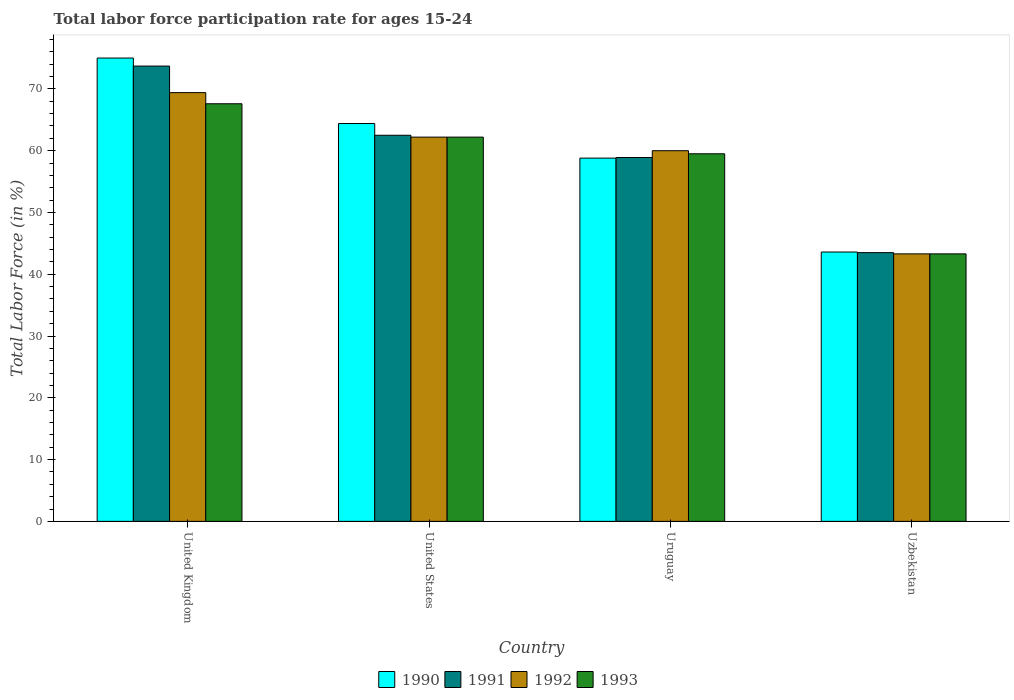How many groups of bars are there?
Give a very brief answer. 4. Are the number of bars per tick equal to the number of legend labels?
Your answer should be very brief. Yes. Are the number of bars on each tick of the X-axis equal?
Offer a terse response. Yes. How many bars are there on the 1st tick from the left?
Your answer should be very brief. 4. How many bars are there on the 4th tick from the right?
Offer a terse response. 4. What is the label of the 2nd group of bars from the left?
Make the answer very short. United States. What is the labor force participation rate in 1991 in Uruguay?
Provide a succinct answer. 58.9. Across all countries, what is the maximum labor force participation rate in 1992?
Keep it short and to the point. 69.4. Across all countries, what is the minimum labor force participation rate in 1991?
Your answer should be compact. 43.5. In which country was the labor force participation rate in 1991 maximum?
Keep it short and to the point. United Kingdom. In which country was the labor force participation rate in 1993 minimum?
Give a very brief answer. Uzbekistan. What is the total labor force participation rate in 1990 in the graph?
Give a very brief answer. 241.8. What is the difference between the labor force participation rate in 1993 in United Kingdom and that in Uruguay?
Your answer should be compact. 8.1. What is the difference between the labor force participation rate in 1991 in United Kingdom and the labor force participation rate in 1990 in Uruguay?
Your answer should be very brief. 14.9. What is the average labor force participation rate in 1993 per country?
Your answer should be very brief. 58.15. What is the difference between the labor force participation rate of/in 1990 and labor force participation rate of/in 1993 in Uzbekistan?
Keep it short and to the point. 0.3. What is the ratio of the labor force participation rate in 1990 in United Kingdom to that in Uzbekistan?
Offer a very short reply. 1.72. Is the labor force participation rate in 1992 in United Kingdom less than that in Uruguay?
Offer a very short reply. No. Is the difference between the labor force participation rate in 1990 in United States and Uzbekistan greater than the difference between the labor force participation rate in 1993 in United States and Uzbekistan?
Make the answer very short. Yes. What is the difference between the highest and the second highest labor force participation rate in 1993?
Your response must be concise. -8.1. What is the difference between the highest and the lowest labor force participation rate in 1990?
Make the answer very short. 31.4. In how many countries, is the labor force participation rate in 1991 greater than the average labor force participation rate in 1991 taken over all countries?
Give a very brief answer. 2. Is the sum of the labor force participation rate in 1991 in Uruguay and Uzbekistan greater than the maximum labor force participation rate in 1992 across all countries?
Provide a succinct answer. Yes. Is it the case that in every country, the sum of the labor force participation rate in 1992 and labor force participation rate in 1991 is greater than the sum of labor force participation rate in 1990 and labor force participation rate in 1993?
Keep it short and to the point. No. Is it the case that in every country, the sum of the labor force participation rate in 1993 and labor force participation rate in 1992 is greater than the labor force participation rate in 1991?
Provide a succinct answer. Yes. How many bars are there?
Your answer should be compact. 16. Are all the bars in the graph horizontal?
Provide a succinct answer. No. How many countries are there in the graph?
Provide a succinct answer. 4. What is the difference between two consecutive major ticks on the Y-axis?
Your answer should be compact. 10. Does the graph contain any zero values?
Your answer should be very brief. No. Does the graph contain grids?
Keep it short and to the point. No. Where does the legend appear in the graph?
Make the answer very short. Bottom center. How are the legend labels stacked?
Your answer should be compact. Horizontal. What is the title of the graph?
Give a very brief answer. Total labor force participation rate for ages 15-24. Does "1965" appear as one of the legend labels in the graph?
Offer a terse response. No. What is the Total Labor Force (in %) in 1991 in United Kingdom?
Provide a succinct answer. 73.7. What is the Total Labor Force (in %) in 1992 in United Kingdom?
Your response must be concise. 69.4. What is the Total Labor Force (in %) in 1993 in United Kingdom?
Offer a terse response. 67.6. What is the Total Labor Force (in %) in 1990 in United States?
Your answer should be compact. 64.4. What is the Total Labor Force (in %) of 1991 in United States?
Offer a very short reply. 62.5. What is the Total Labor Force (in %) of 1992 in United States?
Offer a very short reply. 62.2. What is the Total Labor Force (in %) of 1993 in United States?
Give a very brief answer. 62.2. What is the Total Labor Force (in %) in 1990 in Uruguay?
Offer a very short reply. 58.8. What is the Total Labor Force (in %) of 1991 in Uruguay?
Keep it short and to the point. 58.9. What is the Total Labor Force (in %) of 1992 in Uruguay?
Your response must be concise. 60. What is the Total Labor Force (in %) in 1993 in Uruguay?
Offer a very short reply. 59.5. What is the Total Labor Force (in %) in 1990 in Uzbekistan?
Make the answer very short. 43.6. What is the Total Labor Force (in %) in 1991 in Uzbekistan?
Your answer should be very brief. 43.5. What is the Total Labor Force (in %) in 1992 in Uzbekistan?
Your answer should be compact. 43.3. What is the Total Labor Force (in %) of 1993 in Uzbekistan?
Your response must be concise. 43.3. Across all countries, what is the maximum Total Labor Force (in %) of 1991?
Your answer should be very brief. 73.7. Across all countries, what is the maximum Total Labor Force (in %) in 1992?
Your answer should be very brief. 69.4. Across all countries, what is the maximum Total Labor Force (in %) in 1993?
Ensure brevity in your answer.  67.6. Across all countries, what is the minimum Total Labor Force (in %) in 1990?
Provide a succinct answer. 43.6. Across all countries, what is the minimum Total Labor Force (in %) of 1991?
Provide a short and direct response. 43.5. Across all countries, what is the minimum Total Labor Force (in %) of 1992?
Keep it short and to the point. 43.3. Across all countries, what is the minimum Total Labor Force (in %) in 1993?
Offer a terse response. 43.3. What is the total Total Labor Force (in %) of 1990 in the graph?
Provide a succinct answer. 241.8. What is the total Total Labor Force (in %) of 1991 in the graph?
Your answer should be compact. 238.6. What is the total Total Labor Force (in %) of 1992 in the graph?
Make the answer very short. 234.9. What is the total Total Labor Force (in %) in 1993 in the graph?
Ensure brevity in your answer.  232.6. What is the difference between the Total Labor Force (in %) in 1990 in United Kingdom and that in United States?
Offer a very short reply. 10.6. What is the difference between the Total Labor Force (in %) in 1990 in United Kingdom and that in Uruguay?
Your answer should be very brief. 16.2. What is the difference between the Total Labor Force (in %) of 1990 in United Kingdom and that in Uzbekistan?
Offer a terse response. 31.4. What is the difference between the Total Labor Force (in %) of 1991 in United Kingdom and that in Uzbekistan?
Give a very brief answer. 30.2. What is the difference between the Total Labor Force (in %) of 1992 in United Kingdom and that in Uzbekistan?
Keep it short and to the point. 26.1. What is the difference between the Total Labor Force (in %) of 1993 in United Kingdom and that in Uzbekistan?
Keep it short and to the point. 24.3. What is the difference between the Total Labor Force (in %) in 1990 in United States and that in Uruguay?
Keep it short and to the point. 5.6. What is the difference between the Total Labor Force (in %) of 1990 in United States and that in Uzbekistan?
Your answer should be very brief. 20.8. What is the difference between the Total Labor Force (in %) in 1991 in United States and that in Uzbekistan?
Your answer should be very brief. 19. What is the difference between the Total Labor Force (in %) of 1990 in Uruguay and that in Uzbekistan?
Give a very brief answer. 15.2. What is the difference between the Total Labor Force (in %) in 1992 in Uruguay and that in Uzbekistan?
Provide a succinct answer. 16.7. What is the difference between the Total Labor Force (in %) in 1990 in United Kingdom and the Total Labor Force (in %) in 1991 in United States?
Offer a very short reply. 12.5. What is the difference between the Total Labor Force (in %) in 1990 in United Kingdom and the Total Labor Force (in %) in 1993 in United States?
Your answer should be compact. 12.8. What is the difference between the Total Labor Force (in %) in 1990 in United Kingdom and the Total Labor Force (in %) in 1991 in Uruguay?
Your response must be concise. 16.1. What is the difference between the Total Labor Force (in %) of 1990 in United Kingdom and the Total Labor Force (in %) of 1992 in Uruguay?
Make the answer very short. 15. What is the difference between the Total Labor Force (in %) in 1990 in United Kingdom and the Total Labor Force (in %) in 1993 in Uruguay?
Offer a terse response. 15.5. What is the difference between the Total Labor Force (in %) of 1991 in United Kingdom and the Total Labor Force (in %) of 1993 in Uruguay?
Ensure brevity in your answer.  14.2. What is the difference between the Total Labor Force (in %) of 1992 in United Kingdom and the Total Labor Force (in %) of 1993 in Uruguay?
Your answer should be compact. 9.9. What is the difference between the Total Labor Force (in %) of 1990 in United Kingdom and the Total Labor Force (in %) of 1991 in Uzbekistan?
Provide a short and direct response. 31.5. What is the difference between the Total Labor Force (in %) in 1990 in United Kingdom and the Total Labor Force (in %) in 1992 in Uzbekistan?
Offer a terse response. 31.7. What is the difference between the Total Labor Force (in %) of 1990 in United Kingdom and the Total Labor Force (in %) of 1993 in Uzbekistan?
Give a very brief answer. 31.7. What is the difference between the Total Labor Force (in %) of 1991 in United Kingdom and the Total Labor Force (in %) of 1992 in Uzbekistan?
Offer a very short reply. 30.4. What is the difference between the Total Labor Force (in %) of 1991 in United Kingdom and the Total Labor Force (in %) of 1993 in Uzbekistan?
Provide a short and direct response. 30.4. What is the difference between the Total Labor Force (in %) of 1992 in United Kingdom and the Total Labor Force (in %) of 1993 in Uzbekistan?
Offer a very short reply. 26.1. What is the difference between the Total Labor Force (in %) of 1990 in United States and the Total Labor Force (in %) of 1993 in Uruguay?
Your response must be concise. 4.9. What is the difference between the Total Labor Force (in %) of 1991 in United States and the Total Labor Force (in %) of 1992 in Uruguay?
Ensure brevity in your answer.  2.5. What is the difference between the Total Labor Force (in %) in 1991 in United States and the Total Labor Force (in %) in 1993 in Uruguay?
Your answer should be compact. 3. What is the difference between the Total Labor Force (in %) of 1992 in United States and the Total Labor Force (in %) of 1993 in Uruguay?
Keep it short and to the point. 2.7. What is the difference between the Total Labor Force (in %) of 1990 in United States and the Total Labor Force (in %) of 1991 in Uzbekistan?
Offer a terse response. 20.9. What is the difference between the Total Labor Force (in %) in 1990 in United States and the Total Labor Force (in %) in 1992 in Uzbekistan?
Ensure brevity in your answer.  21.1. What is the difference between the Total Labor Force (in %) of 1990 in United States and the Total Labor Force (in %) of 1993 in Uzbekistan?
Provide a succinct answer. 21.1. What is the difference between the Total Labor Force (in %) in 1991 in United States and the Total Labor Force (in %) in 1992 in Uzbekistan?
Ensure brevity in your answer.  19.2. What is the difference between the Total Labor Force (in %) of 1990 in Uruguay and the Total Labor Force (in %) of 1992 in Uzbekistan?
Your answer should be very brief. 15.5. What is the difference between the Total Labor Force (in %) in 1990 in Uruguay and the Total Labor Force (in %) in 1993 in Uzbekistan?
Ensure brevity in your answer.  15.5. What is the difference between the Total Labor Force (in %) in 1991 in Uruguay and the Total Labor Force (in %) in 1992 in Uzbekistan?
Your answer should be very brief. 15.6. What is the difference between the Total Labor Force (in %) of 1991 in Uruguay and the Total Labor Force (in %) of 1993 in Uzbekistan?
Offer a terse response. 15.6. What is the average Total Labor Force (in %) in 1990 per country?
Provide a succinct answer. 60.45. What is the average Total Labor Force (in %) of 1991 per country?
Give a very brief answer. 59.65. What is the average Total Labor Force (in %) in 1992 per country?
Give a very brief answer. 58.73. What is the average Total Labor Force (in %) of 1993 per country?
Give a very brief answer. 58.15. What is the difference between the Total Labor Force (in %) of 1991 and Total Labor Force (in %) of 1993 in United Kingdom?
Provide a succinct answer. 6.1. What is the difference between the Total Labor Force (in %) of 1990 and Total Labor Force (in %) of 1993 in United States?
Give a very brief answer. 2.2. What is the difference between the Total Labor Force (in %) in 1991 and Total Labor Force (in %) in 1992 in United States?
Your answer should be very brief. 0.3. What is the difference between the Total Labor Force (in %) in 1992 and Total Labor Force (in %) in 1993 in United States?
Ensure brevity in your answer.  0. What is the difference between the Total Labor Force (in %) in 1990 and Total Labor Force (in %) in 1992 in Uruguay?
Offer a terse response. -1.2. What is the difference between the Total Labor Force (in %) of 1992 and Total Labor Force (in %) of 1993 in Uruguay?
Keep it short and to the point. 0.5. What is the difference between the Total Labor Force (in %) of 1991 and Total Labor Force (in %) of 1992 in Uzbekistan?
Make the answer very short. 0.2. What is the difference between the Total Labor Force (in %) of 1991 and Total Labor Force (in %) of 1993 in Uzbekistan?
Your answer should be compact. 0.2. What is the difference between the Total Labor Force (in %) in 1992 and Total Labor Force (in %) in 1993 in Uzbekistan?
Offer a very short reply. 0. What is the ratio of the Total Labor Force (in %) of 1990 in United Kingdom to that in United States?
Your response must be concise. 1.16. What is the ratio of the Total Labor Force (in %) in 1991 in United Kingdom to that in United States?
Give a very brief answer. 1.18. What is the ratio of the Total Labor Force (in %) of 1992 in United Kingdom to that in United States?
Give a very brief answer. 1.12. What is the ratio of the Total Labor Force (in %) in 1993 in United Kingdom to that in United States?
Your answer should be compact. 1.09. What is the ratio of the Total Labor Force (in %) of 1990 in United Kingdom to that in Uruguay?
Your response must be concise. 1.28. What is the ratio of the Total Labor Force (in %) in 1991 in United Kingdom to that in Uruguay?
Make the answer very short. 1.25. What is the ratio of the Total Labor Force (in %) of 1992 in United Kingdom to that in Uruguay?
Provide a succinct answer. 1.16. What is the ratio of the Total Labor Force (in %) in 1993 in United Kingdom to that in Uruguay?
Provide a short and direct response. 1.14. What is the ratio of the Total Labor Force (in %) of 1990 in United Kingdom to that in Uzbekistan?
Your answer should be very brief. 1.72. What is the ratio of the Total Labor Force (in %) in 1991 in United Kingdom to that in Uzbekistan?
Provide a succinct answer. 1.69. What is the ratio of the Total Labor Force (in %) in 1992 in United Kingdom to that in Uzbekistan?
Offer a terse response. 1.6. What is the ratio of the Total Labor Force (in %) in 1993 in United Kingdom to that in Uzbekistan?
Your response must be concise. 1.56. What is the ratio of the Total Labor Force (in %) of 1990 in United States to that in Uruguay?
Offer a very short reply. 1.1. What is the ratio of the Total Labor Force (in %) in 1991 in United States to that in Uruguay?
Keep it short and to the point. 1.06. What is the ratio of the Total Labor Force (in %) of 1992 in United States to that in Uruguay?
Your answer should be very brief. 1.04. What is the ratio of the Total Labor Force (in %) in 1993 in United States to that in Uruguay?
Ensure brevity in your answer.  1.05. What is the ratio of the Total Labor Force (in %) of 1990 in United States to that in Uzbekistan?
Keep it short and to the point. 1.48. What is the ratio of the Total Labor Force (in %) of 1991 in United States to that in Uzbekistan?
Your answer should be very brief. 1.44. What is the ratio of the Total Labor Force (in %) in 1992 in United States to that in Uzbekistan?
Provide a succinct answer. 1.44. What is the ratio of the Total Labor Force (in %) of 1993 in United States to that in Uzbekistan?
Your answer should be very brief. 1.44. What is the ratio of the Total Labor Force (in %) in 1990 in Uruguay to that in Uzbekistan?
Your answer should be very brief. 1.35. What is the ratio of the Total Labor Force (in %) of 1991 in Uruguay to that in Uzbekistan?
Your answer should be very brief. 1.35. What is the ratio of the Total Labor Force (in %) of 1992 in Uruguay to that in Uzbekistan?
Make the answer very short. 1.39. What is the ratio of the Total Labor Force (in %) of 1993 in Uruguay to that in Uzbekistan?
Offer a terse response. 1.37. What is the difference between the highest and the second highest Total Labor Force (in %) in 1991?
Offer a terse response. 11.2. What is the difference between the highest and the second highest Total Labor Force (in %) of 1992?
Make the answer very short. 7.2. What is the difference between the highest and the second highest Total Labor Force (in %) of 1993?
Your answer should be very brief. 5.4. What is the difference between the highest and the lowest Total Labor Force (in %) in 1990?
Make the answer very short. 31.4. What is the difference between the highest and the lowest Total Labor Force (in %) of 1991?
Ensure brevity in your answer.  30.2. What is the difference between the highest and the lowest Total Labor Force (in %) in 1992?
Offer a very short reply. 26.1. What is the difference between the highest and the lowest Total Labor Force (in %) of 1993?
Your response must be concise. 24.3. 